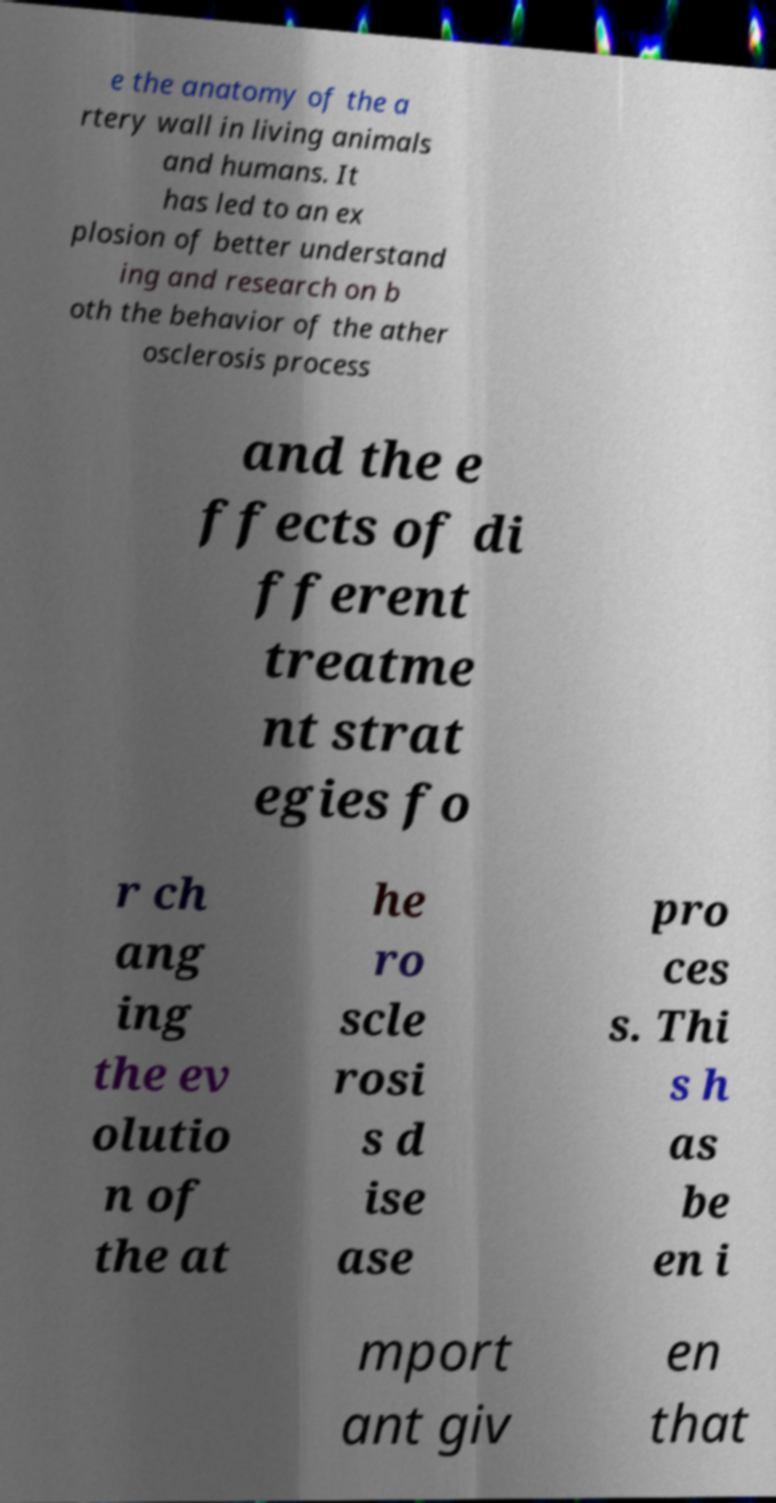I need the written content from this picture converted into text. Can you do that? e the anatomy of the a rtery wall in living animals and humans. It has led to an ex plosion of better understand ing and research on b oth the behavior of the ather osclerosis process and the e ffects of di fferent treatme nt strat egies fo r ch ang ing the ev olutio n of the at he ro scle rosi s d ise ase pro ces s. Thi s h as be en i mport ant giv en that 